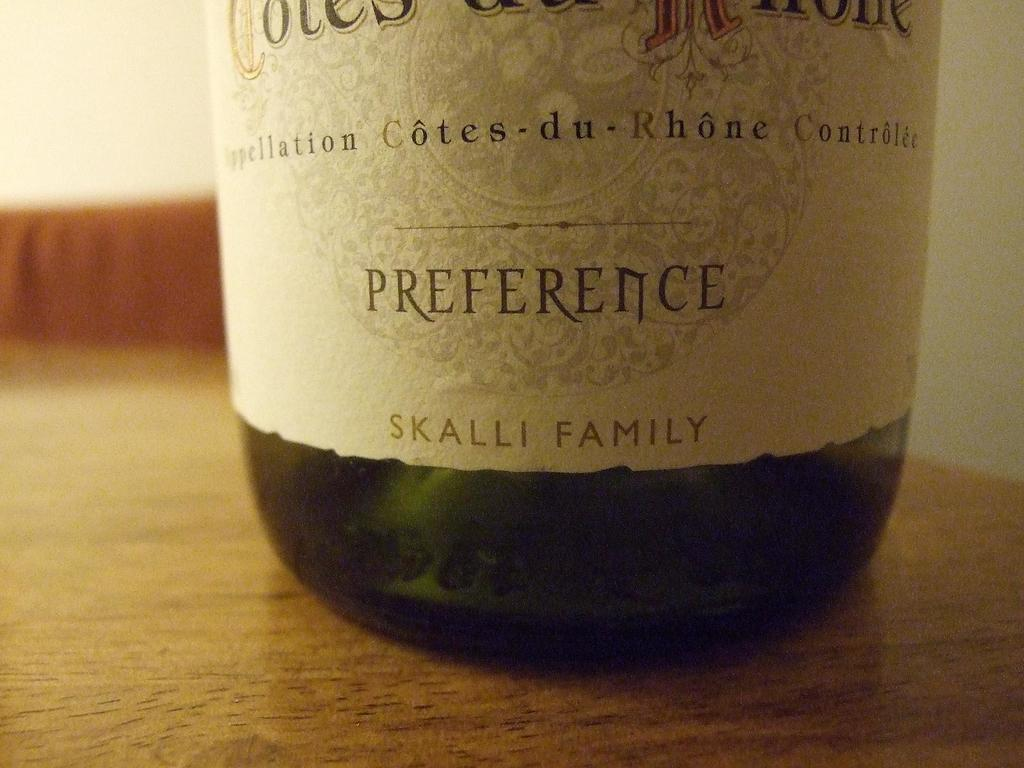Provide a one-sentence caption for the provided image. A bottle of wine by the Skalli family in  green glass. 